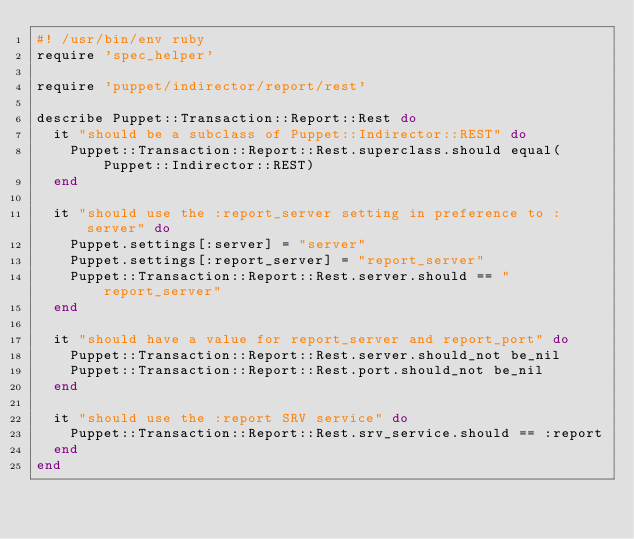<code> <loc_0><loc_0><loc_500><loc_500><_Ruby_>#! /usr/bin/env ruby
require 'spec_helper'

require 'puppet/indirector/report/rest'

describe Puppet::Transaction::Report::Rest do
  it "should be a subclass of Puppet::Indirector::REST" do
    Puppet::Transaction::Report::Rest.superclass.should equal(Puppet::Indirector::REST)
  end

  it "should use the :report_server setting in preference to :server" do
    Puppet.settings[:server] = "server"
    Puppet.settings[:report_server] = "report_server"
    Puppet::Transaction::Report::Rest.server.should == "report_server"
  end

  it "should have a value for report_server and report_port" do
    Puppet::Transaction::Report::Rest.server.should_not be_nil
    Puppet::Transaction::Report::Rest.port.should_not be_nil
  end

  it "should use the :report SRV service" do
    Puppet::Transaction::Report::Rest.srv_service.should == :report
  end
end
</code> 